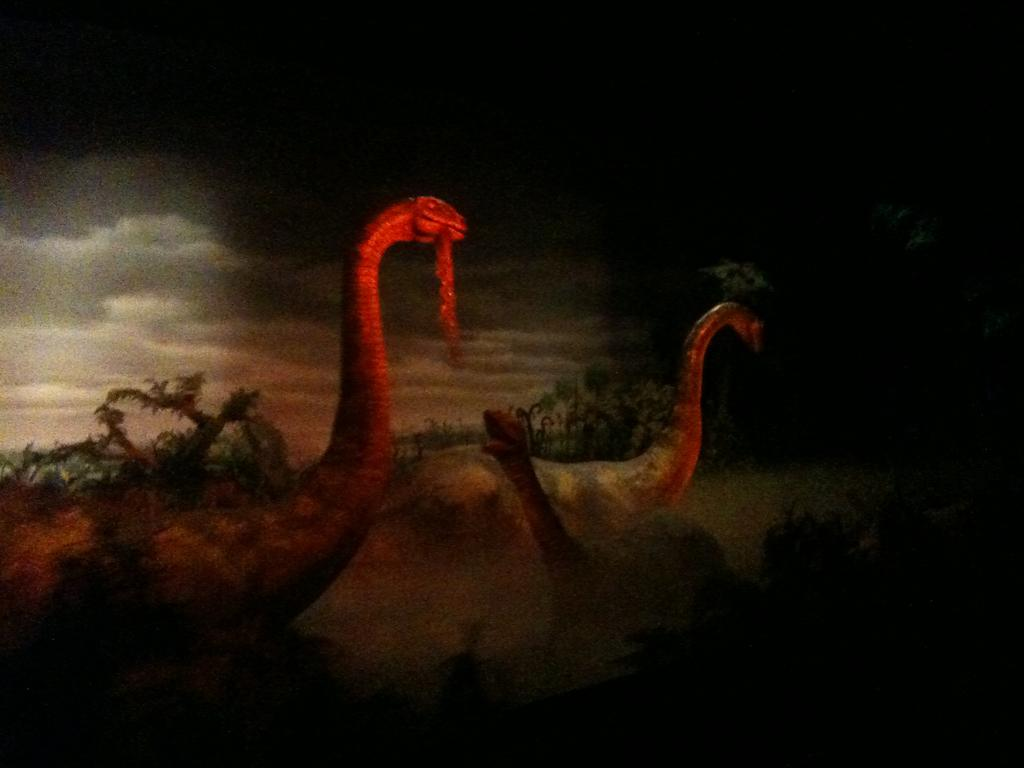What is the main subject of the image? The main subject of the image is a painting. What types of subjects are depicted in the painting? The painting contains animals, trees, and the sky. What type of hobbies can be seen being practiced by the animals in the painting? There are no hobbies depicted in the painting; it only shows animals, trees, and the sky. Can you tell me what color hair the animals in the painting have? There are no animals with hair depicted in the painting; the animals are likely furry or feathered. 